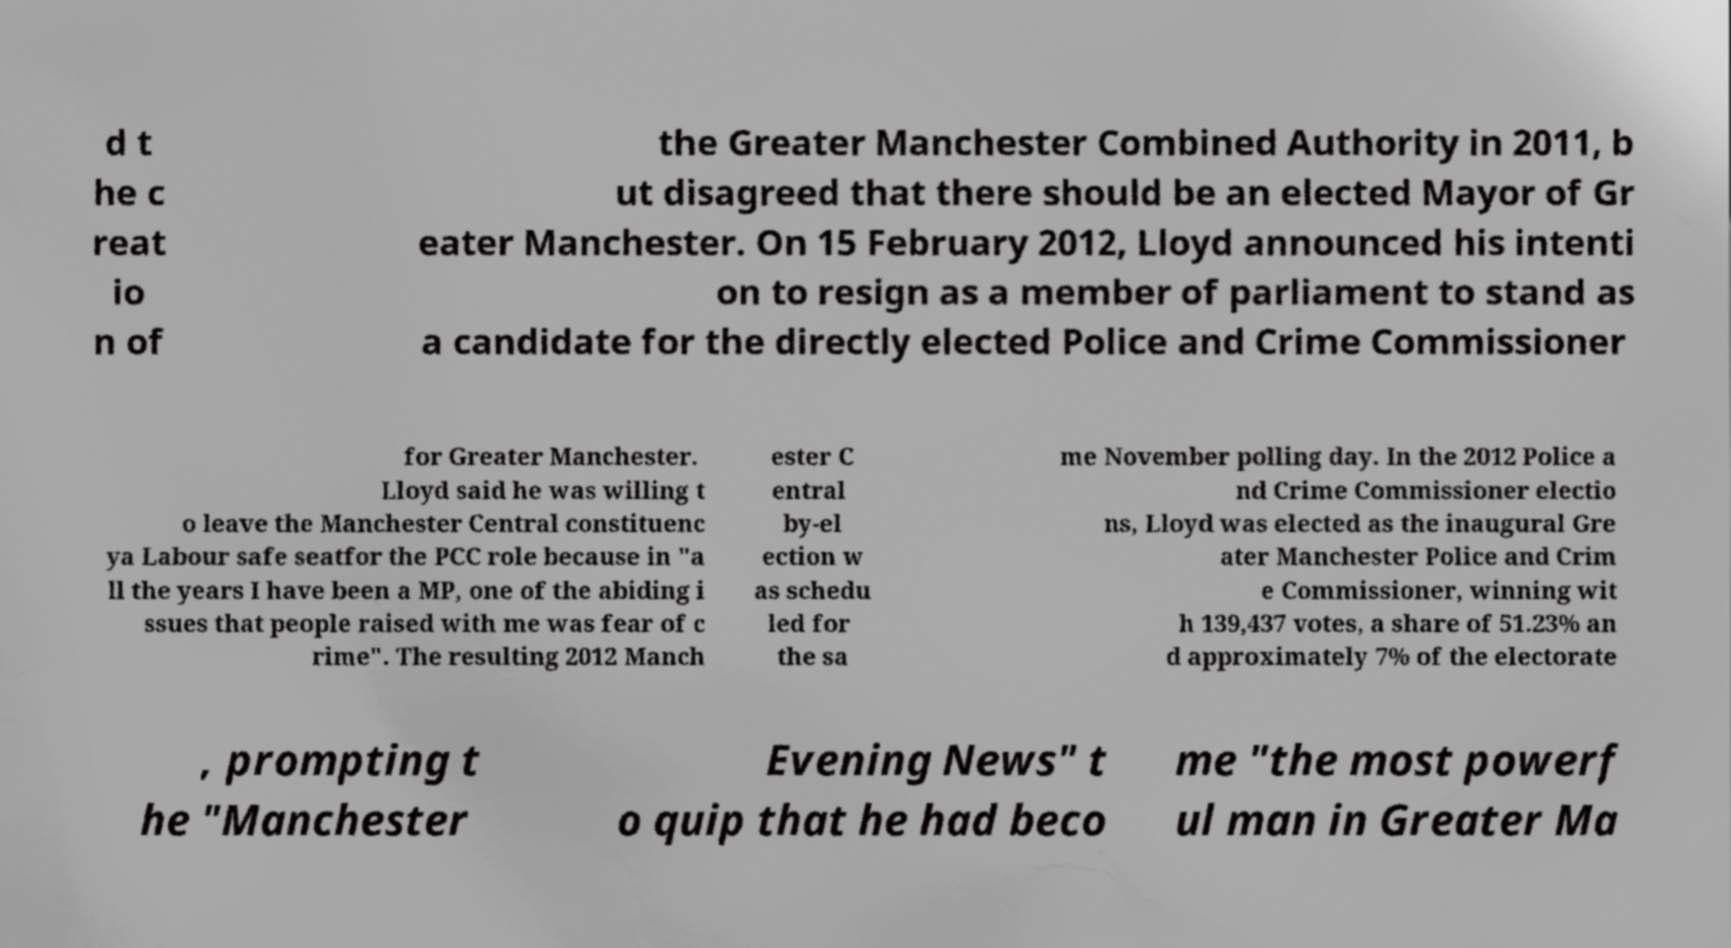Could you extract and type out the text from this image? d t he c reat io n of the Greater Manchester Combined Authority in 2011, b ut disagreed that there should be an elected Mayor of Gr eater Manchester. On 15 February 2012, Lloyd announced his intenti on to resign as a member of parliament to stand as a candidate for the directly elected Police and Crime Commissioner for Greater Manchester. Lloyd said he was willing t o leave the Manchester Central constituenc ya Labour safe seatfor the PCC role because in "a ll the years I have been a MP, one of the abiding i ssues that people raised with me was fear of c rime". The resulting 2012 Manch ester C entral by-el ection w as schedu led for the sa me November polling day. In the 2012 Police a nd Crime Commissioner electio ns, Lloyd was elected as the inaugural Gre ater Manchester Police and Crim e Commissioner, winning wit h 139,437 votes, a share of 51.23% an d approximately 7% of the electorate , prompting t he "Manchester Evening News" t o quip that he had beco me "the most powerf ul man in Greater Ma 